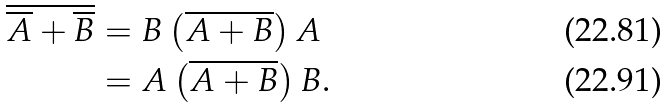<formula> <loc_0><loc_0><loc_500><loc_500>\overline { \overline { A } + \overline { B } } & = B \left ( \overline { A + B } \right ) A \\ & = A \left ( \overline { A + B } \right ) B .</formula> 